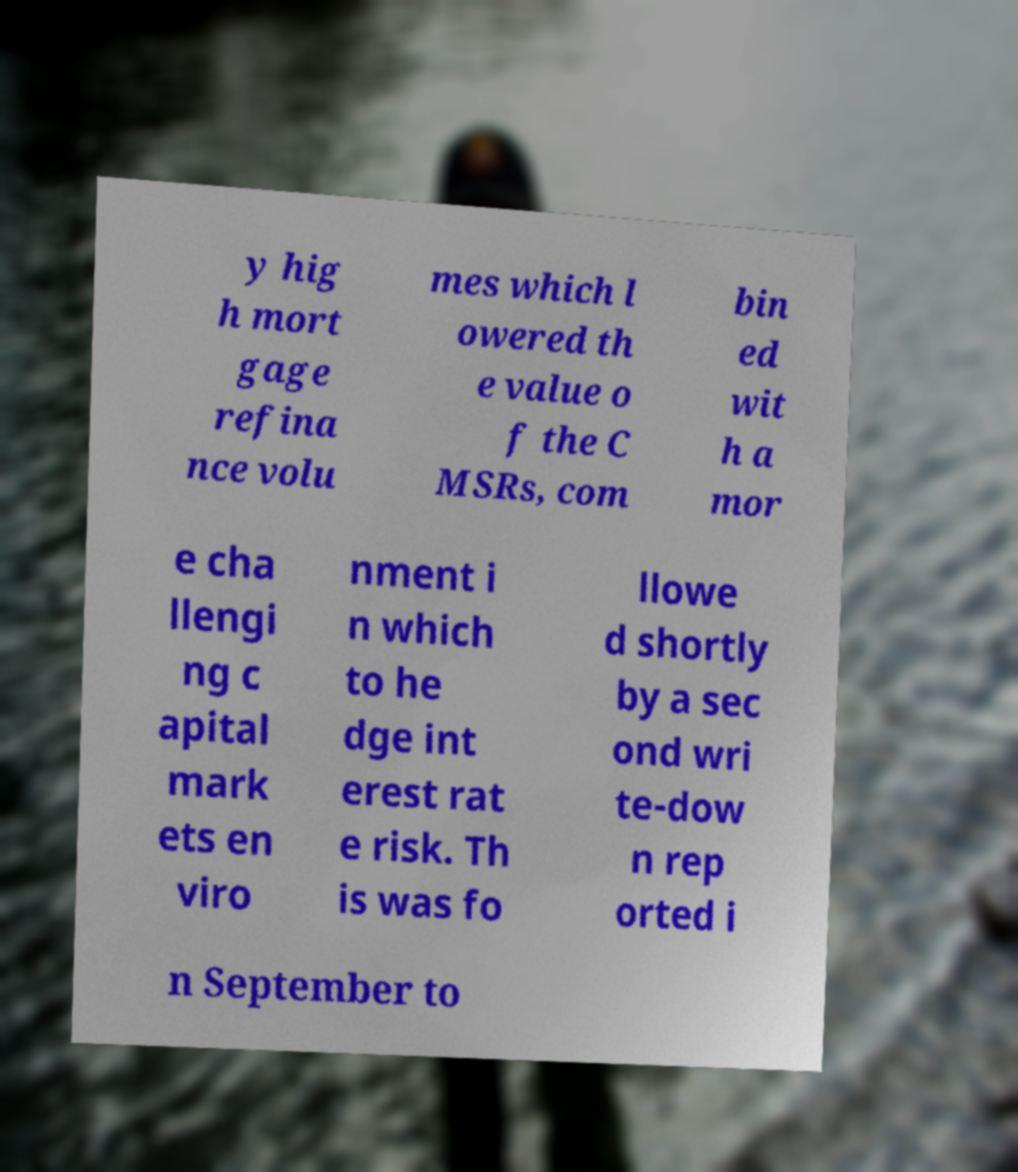There's text embedded in this image that I need extracted. Can you transcribe it verbatim? y hig h mort gage refina nce volu mes which l owered th e value o f the C MSRs, com bin ed wit h a mor e cha llengi ng c apital mark ets en viro nment i n which to he dge int erest rat e risk. Th is was fo llowe d shortly by a sec ond wri te-dow n rep orted i n September to 